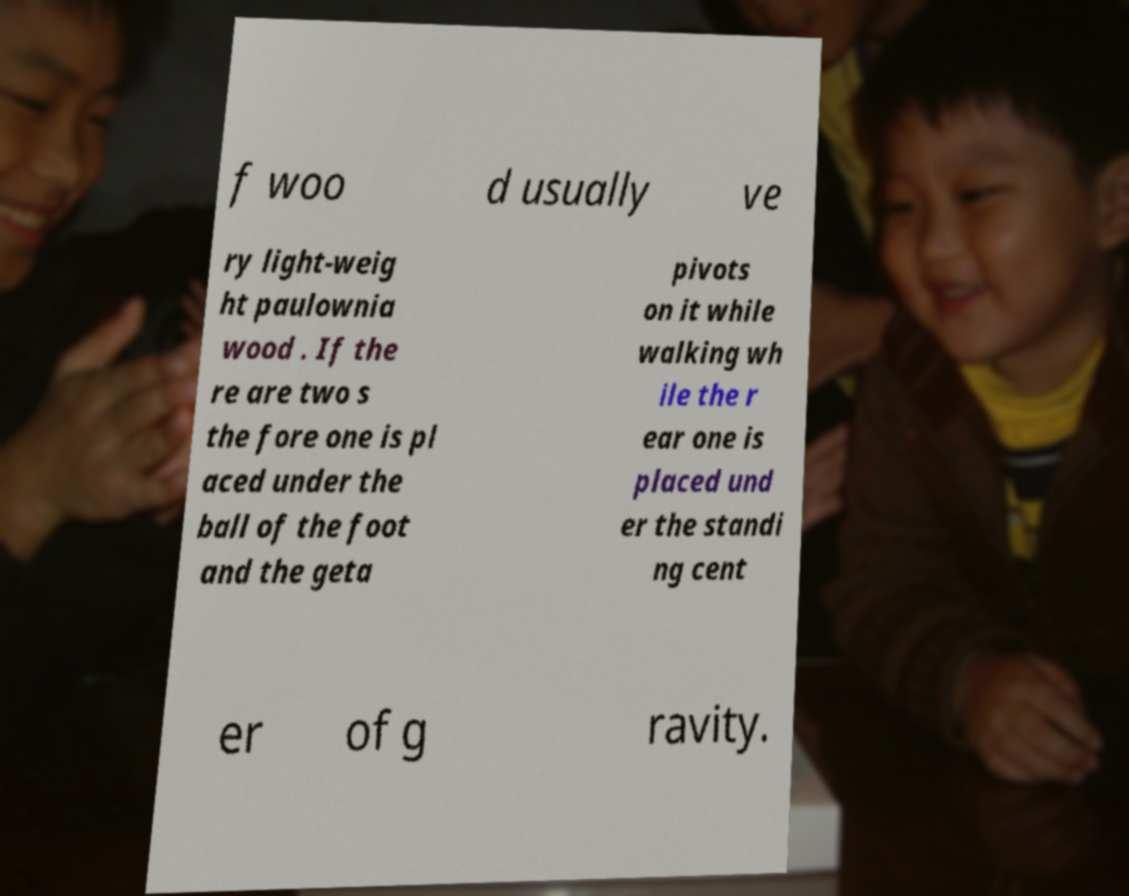Please read and relay the text visible in this image. What does it say? f woo d usually ve ry light-weig ht paulownia wood . If the re are two s the fore one is pl aced under the ball of the foot and the geta pivots on it while walking wh ile the r ear one is placed und er the standi ng cent er of g ravity. 